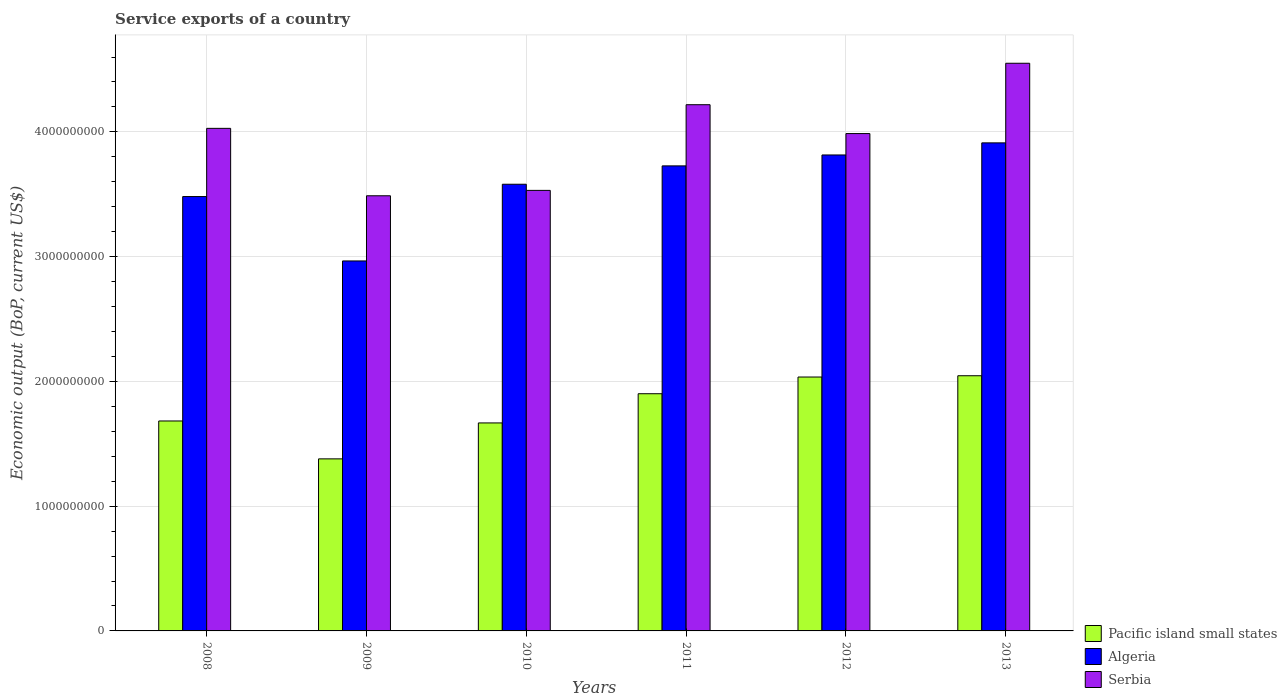How many different coloured bars are there?
Make the answer very short. 3. Are the number of bars on each tick of the X-axis equal?
Make the answer very short. Yes. How many bars are there on the 2nd tick from the left?
Your answer should be very brief. 3. What is the label of the 3rd group of bars from the left?
Your answer should be very brief. 2010. In how many cases, is the number of bars for a given year not equal to the number of legend labels?
Offer a very short reply. 0. What is the service exports in Pacific island small states in 2010?
Offer a terse response. 1.67e+09. Across all years, what is the maximum service exports in Algeria?
Keep it short and to the point. 3.91e+09. Across all years, what is the minimum service exports in Serbia?
Your answer should be compact. 3.49e+09. In which year was the service exports in Algeria maximum?
Your answer should be very brief. 2013. In which year was the service exports in Serbia minimum?
Provide a short and direct response. 2009. What is the total service exports in Serbia in the graph?
Your response must be concise. 2.38e+1. What is the difference between the service exports in Algeria in 2011 and that in 2012?
Your answer should be very brief. -8.75e+07. What is the difference between the service exports in Pacific island small states in 2010 and the service exports in Algeria in 2013?
Provide a short and direct response. -2.24e+09. What is the average service exports in Serbia per year?
Your answer should be compact. 3.97e+09. In the year 2013, what is the difference between the service exports in Serbia and service exports in Algeria?
Give a very brief answer. 6.38e+08. In how many years, is the service exports in Serbia greater than 4400000000 US$?
Offer a terse response. 1. What is the ratio of the service exports in Pacific island small states in 2010 to that in 2011?
Provide a short and direct response. 0.88. Is the service exports in Pacific island small states in 2008 less than that in 2011?
Your answer should be compact. Yes. What is the difference between the highest and the second highest service exports in Pacific island small states?
Provide a short and direct response. 1.04e+07. What is the difference between the highest and the lowest service exports in Algeria?
Your answer should be compact. 9.46e+08. What does the 2nd bar from the left in 2010 represents?
Provide a short and direct response. Algeria. What does the 3rd bar from the right in 2008 represents?
Provide a short and direct response. Pacific island small states. Is it the case that in every year, the sum of the service exports in Serbia and service exports in Pacific island small states is greater than the service exports in Algeria?
Make the answer very short. Yes. Are all the bars in the graph horizontal?
Your answer should be very brief. No. What is the difference between two consecutive major ticks on the Y-axis?
Offer a terse response. 1.00e+09. Does the graph contain any zero values?
Your answer should be very brief. No. Does the graph contain grids?
Make the answer very short. Yes. Where does the legend appear in the graph?
Keep it short and to the point. Bottom right. How are the legend labels stacked?
Make the answer very short. Vertical. What is the title of the graph?
Offer a terse response. Service exports of a country. What is the label or title of the Y-axis?
Provide a short and direct response. Economic output (BoP, current US$). What is the Economic output (BoP, current US$) in Pacific island small states in 2008?
Your answer should be very brief. 1.68e+09. What is the Economic output (BoP, current US$) of Algeria in 2008?
Ensure brevity in your answer.  3.48e+09. What is the Economic output (BoP, current US$) in Serbia in 2008?
Make the answer very short. 4.03e+09. What is the Economic output (BoP, current US$) in Pacific island small states in 2009?
Offer a terse response. 1.38e+09. What is the Economic output (BoP, current US$) in Algeria in 2009?
Your answer should be compact. 2.97e+09. What is the Economic output (BoP, current US$) of Serbia in 2009?
Provide a short and direct response. 3.49e+09. What is the Economic output (BoP, current US$) in Pacific island small states in 2010?
Provide a short and direct response. 1.67e+09. What is the Economic output (BoP, current US$) in Algeria in 2010?
Offer a very short reply. 3.58e+09. What is the Economic output (BoP, current US$) in Serbia in 2010?
Provide a succinct answer. 3.53e+09. What is the Economic output (BoP, current US$) of Pacific island small states in 2011?
Offer a terse response. 1.90e+09. What is the Economic output (BoP, current US$) of Algeria in 2011?
Make the answer very short. 3.73e+09. What is the Economic output (BoP, current US$) in Serbia in 2011?
Your answer should be very brief. 4.22e+09. What is the Economic output (BoP, current US$) of Pacific island small states in 2012?
Offer a very short reply. 2.04e+09. What is the Economic output (BoP, current US$) of Algeria in 2012?
Give a very brief answer. 3.82e+09. What is the Economic output (BoP, current US$) of Serbia in 2012?
Provide a succinct answer. 3.99e+09. What is the Economic output (BoP, current US$) in Pacific island small states in 2013?
Make the answer very short. 2.05e+09. What is the Economic output (BoP, current US$) of Algeria in 2013?
Your answer should be very brief. 3.91e+09. What is the Economic output (BoP, current US$) in Serbia in 2013?
Provide a short and direct response. 4.55e+09. Across all years, what is the maximum Economic output (BoP, current US$) in Pacific island small states?
Provide a succinct answer. 2.05e+09. Across all years, what is the maximum Economic output (BoP, current US$) in Algeria?
Your answer should be compact. 3.91e+09. Across all years, what is the maximum Economic output (BoP, current US$) in Serbia?
Provide a short and direct response. 4.55e+09. Across all years, what is the minimum Economic output (BoP, current US$) of Pacific island small states?
Make the answer very short. 1.38e+09. Across all years, what is the minimum Economic output (BoP, current US$) in Algeria?
Your answer should be compact. 2.97e+09. Across all years, what is the minimum Economic output (BoP, current US$) in Serbia?
Offer a very short reply. 3.49e+09. What is the total Economic output (BoP, current US$) of Pacific island small states in the graph?
Ensure brevity in your answer.  1.07e+1. What is the total Economic output (BoP, current US$) of Algeria in the graph?
Your response must be concise. 2.15e+1. What is the total Economic output (BoP, current US$) of Serbia in the graph?
Offer a terse response. 2.38e+1. What is the difference between the Economic output (BoP, current US$) of Pacific island small states in 2008 and that in 2009?
Your answer should be very brief. 3.04e+08. What is the difference between the Economic output (BoP, current US$) of Algeria in 2008 and that in 2009?
Provide a short and direct response. 5.16e+08. What is the difference between the Economic output (BoP, current US$) in Serbia in 2008 and that in 2009?
Ensure brevity in your answer.  5.40e+08. What is the difference between the Economic output (BoP, current US$) of Pacific island small states in 2008 and that in 2010?
Your answer should be compact. 1.57e+07. What is the difference between the Economic output (BoP, current US$) in Algeria in 2008 and that in 2010?
Your answer should be compact. -9.86e+07. What is the difference between the Economic output (BoP, current US$) in Serbia in 2008 and that in 2010?
Provide a short and direct response. 4.97e+08. What is the difference between the Economic output (BoP, current US$) of Pacific island small states in 2008 and that in 2011?
Ensure brevity in your answer.  -2.18e+08. What is the difference between the Economic output (BoP, current US$) in Algeria in 2008 and that in 2011?
Make the answer very short. -2.46e+08. What is the difference between the Economic output (BoP, current US$) in Serbia in 2008 and that in 2011?
Give a very brief answer. -1.90e+08. What is the difference between the Economic output (BoP, current US$) in Pacific island small states in 2008 and that in 2012?
Make the answer very short. -3.52e+08. What is the difference between the Economic output (BoP, current US$) of Algeria in 2008 and that in 2012?
Your response must be concise. -3.33e+08. What is the difference between the Economic output (BoP, current US$) of Serbia in 2008 and that in 2012?
Ensure brevity in your answer.  4.19e+07. What is the difference between the Economic output (BoP, current US$) of Pacific island small states in 2008 and that in 2013?
Provide a short and direct response. -3.63e+08. What is the difference between the Economic output (BoP, current US$) in Algeria in 2008 and that in 2013?
Offer a very short reply. -4.30e+08. What is the difference between the Economic output (BoP, current US$) in Serbia in 2008 and that in 2013?
Provide a short and direct response. -5.22e+08. What is the difference between the Economic output (BoP, current US$) in Pacific island small states in 2009 and that in 2010?
Provide a succinct answer. -2.88e+08. What is the difference between the Economic output (BoP, current US$) in Algeria in 2009 and that in 2010?
Offer a very short reply. -6.15e+08. What is the difference between the Economic output (BoP, current US$) in Serbia in 2009 and that in 2010?
Ensure brevity in your answer.  -4.33e+07. What is the difference between the Economic output (BoP, current US$) of Pacific island small states in 2009 and that in 2011?
Give a very brief answer. -5.22e+08. What is the difference between the Economic output (BoP, current US$) in Algeria in 2009 and that in 2011?
Ensure brevity in your answer.  -7.62e+08. What is the difference between the Economic output (BoP, current US$) of Serbia in 2009 and that in 2011?
Your answer should be compact. -7.30e+08. What is the difference between the Economic output (BoP, current US$) of Pacific island small states in 2009 and that in 2012?
Keep it short and to the point. -6.56e+08. What is the difference between the Economic output (BoP, current US$) of Algeria in 2009 and that in 2012?
Ensure brevity in your answer.  -8.50e+08. What is the difference between the Economic output (BoP, current US$) of Serbia in 2009 and that in 2012?
Provide a short and direct response. -4.99e+08. What is the difference between the Economic output (BoP, current US$) of Pacific island small states in 2009 and that in 2013?
Keep it short and to the point. -6.66e+08. What is the difference between the Economic output (BoP, current US$) of Algeria in 2009 and that in 2013?
Your answer should be very brief. -9.46e+08. What is the difference between the Economic output (BoP, current US$) of Serbia in 2009 and that in 2013?
Offer a terse response. -1.06e+09. What is the difference between the Economic output (BoP, current US$) in Pacific island small states in 2010 and that in 2011?
Make the answer very short. -2.34e+08. What is the difference between the Economic output (BoP, current US$) of Algeria in 2010 and that in 2011?
Keep it short and to the point. -1.47e+08. What is the difference between the Economic output (BoP, current US$) of Serbia in 2010 and that in 2011?
Your answer should be very brief. -6.87e+08. What is the difference between the Economic output (BoP, current US$) in Pacific island small states in 2010 and that in 2012?
Offer a terse response. -3.68e+08. What is the difference between the Economic output (BoP, current US$) of Algeria in 2010 and that in 2012?
Your answer should be compact. -2.35e+08. What is the difference between the Economic output (BoP, current US$) in Serbia in 2010 and that in 2012?
Your response must be concise. -4.55e+08. What is the difference between the Economic output (BoP, current US$) of Pacific island small states in 2010 and that in 2013?
Your response must be concise. -3.78e+08. What is the difference between the Economic output (BoP, current US$) of Algeria in 2010 and that in 2013?
Your response must be concise. -3.32e+08. What is the difference between the Economic output (BoP, current US$) of Serbia in 2010 and that in 2013?
Offer a terse response. -1.02e+09. What is the difference between the Economic output (BoP, current US$) in Pacific island small states in 2011 and that in 2012?
Ensure brevity in your answer.  -1.34e+08. What is the difference between the Economic output (BoP, current US$) in Algeria in 2011 and that in 2012?
Provide a short and direct response. -8.75e+07. What is the difference between the Economic output (BoP, current US$) in Serbia in 2011 and that in 2012?
Keep it short and to the point. 2.31e+08. What is the difference between the Economic output (BoP, current US$) of Pacific island small states in 2011 and that in 2013?
Your answer should be very brief. -1.44e+08. What is the difference between the Economic output (BoP, current US$) in Algeria in 2011 and that in 2013?
Offer a terse response. -1.85e+08. What is the difference between the Economic output (BoP, current US$) of Serbia in 2011 and that in 2013?
Make the answer very short. -3.32e+08. What is the difference between the Economic output (BoP, current US$) in Pacific island small states in 2012 and that in 2013?
Your answer should be compact. -1.04e+07. What is the difference between the Economic output (BoP, current US$) of Algeria in 2012 and that in 2013?
Keep it short and to the point. -9.70e+07. What is the difference between the Economic output (BoP, current US$) in Serbia in 2012 and that in 2013?
Offer a very short reply. -5.64e+08. What is the difference between the Economic output (BoP, current US$) in Pacific island small states in 2008 and the Economic output (BoP, current US$) in Algeria in 2009?
Offer a very short reply. -1.28e+09. What is the difference between the Economic output (BoP, current US$) in Pacific island small states in 2008 and the Economic output (BoP, current US$) in Serbia in 2009?
Your answer should be compact. -1.80e+09. What is the difference between the Economic output (BoP, current US$) in Algeria in 2008 and the Economic output (BoP, current US$) in Serbia in 2009?
Provide a short and direct response. -6.19e+06. What is the difference between the Economic output (BoP, current US$) in Pacific island small states in 2008 and the Economic output (BoP, current US$) in Algeria in 2010?
Provide a short and direct response. -1.90e+09. What is the difference between the Economic output (BoP, current US$) of Pacific island small states in 2008 and the Economic output (BoP, current US$) of Serbia in 2010?
Provide a succinct answer. -1.85e+09. What is the difference between the Economic output (BoP, current US$) in Algeria in 2008 and the Economic output (BoP, current US$) in Serbia in 2010?
Your answer should be very brief. -4.95e+07. What is the difference between the Economic output (BoP, current US$) of Pacific island small states in 2008 and the Economic output (BoP, current US$) of Algeria in 2011?
Provide a succinct answer. -2.04e+09. What is the difference between the Economic output (BoP, current US$) in Pacific island small states in 2008 and the Economic output (BoP, current US$) in Serbia in 2011?
Give a very brief answer. -2.53e+09. What is the difference between the Economic output (BoP, current US$) of Algeria in 2008 and the Economic output (BoP, current US$) of Serbia in 2011?
Your response must be concise. -7.36e+08. What is the difference between the Economic output (BoP, current US$) in Pacific island small states in 2008 and the Economic output (BoP, current US$) in Algeria in 2012?
Offer a terse response. -2.13e+09. What is the difference between the Economic output (BoP, current US$) in Pacific island small states in 2008 and the Economic output (BoP, current US$) in Serbia in 2012?
Provide a succinct answer. -2.30e+09. What is the difference between the Economic output (BoP, current US$) of Algeria in 2008 and the Economic output (BoP, current US$) of Serbia in 2012?
Make the answer very short. -5.05e+08. What is the difference between the Economic output (BoP, current US$) of Pacific island small states in 2008 and the Economic output (BoP, current US$) of Algeria in 2013?
Your answer should be compact. -2.23e+09. What is the difference between the Economic output (BoP, current US$) of Pacific island small states in 2008 and the Economic output (BoP, current US$) of Serbia in 2013?
Your answer should be compact. -2.87e+09. What is the difference between the Economic output (BoP, current US$) of Algeria in 2008 and the Economic output (BoP, current US$) of Serbia in 2013?
Ensure brevity in your answer.  -1.07e+09. What is the difference between the Economic output (BoP, current US$) of Pacific island small states in 2009 and the Economic output (BoP, current US$) of Algeria in 2010?
Ensure brevity in your answer.  -2.20e+09. What is the difference between the Economic output (BoP, current US$) of Pacific island small states in 2009 and the Economic output (BoP, current US$) of Serbia in 2010?
Your response must be concise. -2.15e+09. What is the difference between the Economic output (BoP, current US$) of Algeria in 2009 and the Economic output (BoP, current US$) of Serbia in 2010?
Provide a short and direct response. -5.66e+08. What is the difference between the Economic output (BoP, current US$) in Pacific island small states in 2009 and the Economic output (BoP, current US$) in Algeria in 2011?
Ensure brevity in your answer.  -2.35e+09. What is the difference between the Economic output (BoP, current US$) in Pacific island small states in 2009 and the Economic output (BoP, current US$) in Serbia in 2011?
Provide a short and direct response. -2.84e+09. What is the difference between the Economic output (BoP, current US$) in Algeria in 2009 and the Economic output (BoP, current US$) in Serbia in 2011?
Your answer should be very brief. -1.25e+09. What is the difference between the Economic output (BoP, current US$) of Pacific island small states in 2009 and the Economic output (BoP, current US$) of Algeria in 2012?
Ensure brevity in your answer.  -2.44e+09. What is the difference between the Economic output (BoP, current US$) in Pacific island small states in 2009 and the Economic output (BoP, current US$) in Serbia in 2012?
Offer a very short reply. -2.61e+09. What is the difference between the Economic output (BoP, current US$) in Algeria in 2009 and the Economic output (BoP, current US$) in Serbia in 2012?
Make the answer very short. -1.02e+09. What is the difference between the Economic output (BoP, current US$) of Pacific island small states in 2009 and the Economic output (BoP, current US$) of Algeria in 2013?
Provide a short and direct response. -2.53e+09. What is the difference between the Economic output (BoP, current US$) in Pacific island small states in 2009 and the Economic output (BoP, current US$) in Serbia in 2013?
Offer a very short reply. -3.17e+09. What is the difference between the Economic output (BoP, current US$) in Algeria in 2009 and the Economic output (BoP, current US$) in Serbia in 2013?
Your answer should be very brief. -1.58e+09. What is the difference between the Economic output (BoP, current US$) in Pacific island small states in 2010 and the Economic output (BoP, current US$) in Algeria in 2011?
Your answer should be compact. -2.06e+09. What is the difference between the Economic output (BoP, current US$) of Pacific island small states in 2010 and the Economic output (BoP, current US$) of Serbia in 2011?
Offer a very short reply. -2.55e+09. What is the difference between the Economic output (BoP, current US$) of Algeria in 2010 and the Economic output (BoP, current US$) of Serbia in 2011?
Provide a succinct answer. -6.38e+08. What is the difference between the Economic output (BoP, current US$) of Pacific island small states in 2010 and the Economic output (BoP, current US$) of Algeria in 2012?
Your answer should be very brief. -2.15e+09. What is the difference between the Economic output (BoP, current US$) in Pacific island small states in 2010 and the Economic output (BoP, current US$) in Serbia in 2012?
Offer a very short reply. -2.32e+09. What is the difference between the Economic output (BoP, current US$) in Algeria in 2010 and the Economic output (BoP, current US$) in Serbia in 2012?
Provide a succinct answer. -4.06e+08. What is the difference between the Economic output (BoP, current US$) of Pacific island small states in 2010 and the Economic output (BoP, current US$) of Algeria in 2013?
Offer a terse response. -2.24e+09. What is the difference between the Economic output (BoP, current US$) in Pacific island small states in 2010 and the Economic output (BoP, current US$) in Serbia in 2013?
Make the answer very short. -2.88e+09. What is the difference between the Economic output (BoP, current US$) of Algeria in 2010 and the Economic output (BoP, current US$) of Serbia in 2013?
Offer a terse response. -9.70e+08. What is the difference between the Economic output (BoP, current US$) of Pacific island small states in 2011 and the Economic output (BoP, current US$) of Algeria in 2012?
Offer a terse response. -1.91e+09. What is the difference between the Economic output (BoP, current US$) of Pacific island small states in 2011 and the Economic output (BoP, current US$) of Serbia in 2012?
Provide a short and direct response. -2.09e+09. What is the difference between the Economic output (BoP, current US$) in Algeria in 2011 and the Economic output (BoP, current US$) in Serbia in 2012?
Give a very brief answer. -2.59e+08. What is the difference between the Economic output (BoP, current US$) of Pacific island small states in 2011 and the Economic output (BoP, current US$) of Algeria in 2013?
Provide a short and direct response. -2.01e+09. What is the difference between the Economic output (BoP, current US$) of Pacific island small states in 2011 and the Economic output (BoP, current US$) of Serbia in 2013?
Keep it short and to the point. -2.65e+09. What is the difference between the Economic output (BoP, current US$) of Algeria in 2011 and the Economic output (BoP, current US$) of Serbia in 2013?
Make the answer very short. -8.23e+08. What is the difference between the Economic output (BoP, current US$) of Pacific island small states in 2012 and the Economic output (BoP, current US$) of Algeria in 2013?
Your answer should be compact. -1.88e+09. What is the difference between the Economic output (BoP, current US$) of Pacific island small states in 2012 and the Economic output (BoP, current US$) of Serbia in 2013?
Ensure brevity in your answer.  -2.52e+09. What is the difference between the Economic output (BoP, current US$) of Algeria in 2012 and the Economic output (BoP, current US$) of Serbia in 2013?
Keep it short and to the point. -7.35e+08. What is the average Economic output (BoP, current US$) of Pacific island small states per year?
Offer a very short reply. 1.79e+09. What is the average Economic output (BoP, current US$) in Algeria per year?
Provide a succinct answer. 3.58e+09. What is the average Economic output (BoP, current US$) in Serbia per year?
Your answer should be very brief. 3.97e+09. In the year 2008, what is the difference between the Economic output (BoP, current US$) of Pacific island small states and Economic output (BoP, current US$) of Algeria?
Offer a very short reply. -1.80e+09. In the year 2008, what is the difference between the Economic output (BoP, current US$) in Pacific island small states and Economic output (BoP, current US$) in Serbia?
Your answer should be very brief. -2.35e+09. In the year 2008, what is the difference between the Economic output (BoP, current US$) in Algeria and Economic output (BoP, current US$) in Serbia?
Provide a succinct answer. -5.47e+08. In the year 2009, what is the difference between the Economic output (BoP, current US$) in Pacific island small states and Economic output (BoP, current US$) in Algeria?
Give a very brief answer. -1.59e+09. In the year 2009, what is the difference between the Economic output (BoP, current US$) in Pacific island small states and Economic output (BoP, current US$) in Serbia?
Keep it short and to the point. -2.11e+09. In the year 2009, what is the difference between the Economic output (BoP, current US$) of Algeria and Economic output (BoP, current US$) of Serbia?
Give a very brief answer. -5.22e+08. In the year 2010, what is the difference between the Economic output (BoP, current US$) of Pacific island small states and Economic output (BoP, current US$) of Algeria?
Give a very brief answer. -1.91e+09. In the year 2010, what is the difference between the Economic output (BoP, current US$) in Pacific island small states and Economic output (BoP, current US$) in Serbia?
Provide a short and direct response. -1.86e+09. In the year 2010, what is the difference between the Economic output (BoP, current US$) of Algeria and Economic output (BoP, current US$) of Serbia?
Offer a terse response. 4.92e+07. In the year 2011, what is the difference between the Economic output (BoP, current US$) of Pacific island small states and Economic output (BoP, current US$) of Algeria?
Ensure brevity in your answer.  -1.83e+09. In the year 2011, what is the difference between the Economic output (BoP, current US$) in Pacific island small states and Economic output (BoP, current US$) in Serbia?
Your answer should be compact. -2.32e+09. In the year 2011, what is the difference between the Economic output (BoP, current US$) of Algeria and Economic output (BoP, current US$) of Serbia?
Your response must be concise. -4.90e+08. In the year 2012, what is the difference between the Economic output (BoP, current US$) of Pacific island small states and Economic output (BoP, current US$) of Algeria?
Make the answer very short. -1.78e+09. In the year 2012, what is the difference between the Economic output (BoP, current US$) of Pacific island small states and Economic output (BoP, current US$) of Serbia?
Give a very brief answer. -1.95e+09. In the year 2012, what is the difference between the Economic output (BoP, current US$) in Algeria and Economic output (BoP, current US$) in Serbia?
Provide a short and direct response. -1.71e+08. In the year 2013, what is the difference between the Economic output (BoP, current US$) in Pacific island small states and Economic output (BoP, current US$) in Algeria?
Make the answer very short. -1.87e+09. In the year 2013, what is the difference between the Economic output (BoP, current US$) in Pacific island small states and Economic output (BoP, current US$) in Serbia?
Your answer should be compact. -2.50e+09. In the year 2013, what is the difference between the Economic output (BoP, current US$) in Algeria and Economic output (BoP, current US$) in Serbia?
Your answer should be very brief. -6.38e+08. What is the ratio of the Economic output (BoP, current US$) of Pacific island small states in 2008 to that in 2009?
Provide a short and direct response. 1.22. What is the ratio of the Economic output (BoP, current US$) of Algeria in 2008 to that in 2009?
Ensure brevity in your answer.  1.17. What is the ratio of the Economic output (BoP, current US$) in Serbia in 2008 to that in 2009?
Provide a succinct answer. 1.16. What is the ratio of the Economic output (BoP, current US$) in Pacific island small states in 2008 to that in 2010?
Make the answer very short. 1.01. What is the ratio of the Economic output (BoP, current US$) in Algeria in 2008 to that in 2010?
Offer a terse response. 0.97. What is the ratio of the Economic output (BoP, current US$) of Serbia in 2008 to that in 2010?
Your answer should be compact. 1.14. What is the ratio of the Economic output (BoP, current US$) of Pacific island small states in 2008 to that in 2011?
Your answer should be very brief. 0.89. What is the ratio of the Economic output (BoP, current US$) in Algeria in 2008 to that in 2011?
Offer a terse response. 0.93. What is the ratio of the Economic output (BoP, current US$) of Serbia in 2008 to that in 2011?
Keep it short and to the point. 0.96. What is the ratio of the Economic output (BoP, current US$) of Pacific island small states in 2008 to that in 2012?
Ensure brevity in your answer.  0.83. What is the ratio of the Economic output (BoP, current US$) in Algeria in 2008 to that in 2012?
Make the answer very short. 0.91. What is the ratio of the Economic output (BoP, current US$) of Serbia in 2008 to that in 2012?
Your answer should be very brief. 1.01. What is the ratio of the Economic output (BoP, current US$) in Pacific island small states in 2008 to that in 2013?
Keep it short and to the point. 0.82. What is the ratio of the Economic output (BoP, current US$) of Algeria in 2008 to that in 2013?
Your response must be concise. 0.89. What is the ratio of the Economic output (BoP, current US$) in Serbia in 2008 to that in 2013?
Give a very brief answer. 0.89. What is the ratio of the Economic output (BoP, current US$) in Pacific island small states in 2009 to that in 2010?
Your answer should be compact. 0.83. What is the ratio of the Economic output (BoP, current US$) of Algeria in 2009 to that in 2010?
Your answer should be compact. 0.83. What is the ratio of the Economic output (BoP, current US$) in Pacific island small states in 2009 to that in 2011?
Your response must be concise. 0.73. What is the ratio of the Economic output (BoP, current US$) of Algeria in 2009 to that in 2011?
Give a very brief answer. 0.8. What is the ratio of the Economic output (BoP, current US$) in Serbia in 2009 to that in 2011?
Keep it short and to the point. 0.83. What is the ratio of the Economic output (BoP, current US$) of Pacific island small states in 2009 to that in 2012?
Keep it short and to the point. 0.68. What is the ratio of the Economic output (BoP, current US$) of Algeria in 2009 to that in 2012?
Your answer should be very brief. 0.78. What is the ratio of the Economic output (BoP, current US$) of Serbia in 2009 to that in 2012?
Your response must be concise. 0.87. What is the ratio of the Economic output (BoP, current US$) in Pacific island small states in 2009 to that in 2013?
Ensure brevity in your answer.  0.67. What is the ratio of the Economic output (BoP, current US$) in Algeria in 2009 to that in 2013?
Provide a succinct answer. 0.76. What is the ratio of the Economic output (BoP, current US$) of Serbia in 2009 to that in 2013?
Offer a terse response. 0.77. What is the ratio of the Economic output (BoP, current US$) in Pacific island small states in 2010 to that in 2011?
Your answer should be compact. 0.88. What is the ratio of the Economic output (BoP, current US$) in Algeria in 2010 to that in 2011?
Offer a very short reply. 0.96. What is the ratio of the Economic output (BoP, current US$) of Serbia in 2010 to that in 2011?
Your response must be concise. 0.84. What is the ratio of the Economic output (BoP, current US$) in Pacific island small states in 2010 to that in 2012?
Keep it short and to the point. 0.82. What is the ratio of the Economic output (BoP, current US$) of Algeria in 2010 to that in 2012?
Offer a very short reply. 0.94. What is the ratio of the Economic output (BoP, current US$) of Serbia in 2010 to that in 2012?
Keep it short and to the point. 0.89. What is the ratio of the Economic output (BoP, current US$) in Pacific island small states in 2010 to that in 2013?
Make the answer very short. 0.82. What is the ratio of the Economic output (BoP, current US$) in Algeria in 2010 to that in 2013?
Give a very brief answer. 0.92. What is the ratio of the Economic output (BoP, current US$) of Serbia in 2010 to that in 2013?
Your response must be concise. 0.78. What is the ratio of the Economic output (BoP, current US$) of Pacific island small states in 2011 to that in 2012?
Your response must be concise. 0.93. What is the ratio of the Economic output (BoP, current US$) of Algeria in 2011 to that in 2012?
Make the answer very short. 0.98. What is the ratio of the Economic output (BoP, current US$) of Serbia in 2011 to that in 2012?
Provide a short and direct response. 1.06. What is the ratio of the Economic output (BoP, current US$) of Pacific island small states in 2011 to that in 2013?
Make the answer very short. 0.93. What is the ratio of the Economic output (BoP, current US$) in Algeria in 2011 to that in 2013?
Give a very brief answer. 0.95. What is the ratio of the Economic output (BoP, current US$) of Serbia in 2011 to that in 2013?
Give a very brief answer. 0.93. What is the ratio of the Economic output (BoP, current US$) of Pacific island small states in 2012 to that in 2013?
Make the answer very short. 0.99. What is the ratio of the Economic output (BoP, current US$) of Algeria in 2012 to that in 2013?
Your response must be concise. 0.98. What is the ratio of the Economic output (BoP, current US$) in Serbia in 2012 to that in 2013?
Your answer should be very brief. 0.88. What is the difference between the highest and the second highest Economic output (BoP, current US$) of Pacific island small states?
Keep it short and to the point. 1.04e+07. What is the difference between the highest and the second highest Economic output (BoP, current US$) in Algeria?
Provide a short and direct response. 9.70e+07. What is the difference between the highest and the second highest Economic output (BoP, current US$) in Serbia?
Ensure brevity in your answer.  3.32e+08. What is the difference between the highest and the lowest Economic output (BoP, current US$) in Pacific island small states?
Provide a short and direct response. 6.66e+08. What is the difference between the highest and the lowest Economic output (BoP, current US$) in Algeria?
Provide a short and direct response. 9.46e+08. What is the difference between the highest and the lowest Economic output (BoP, current US$) of Serbia?
Make the answer very short. 1.06e+09. 